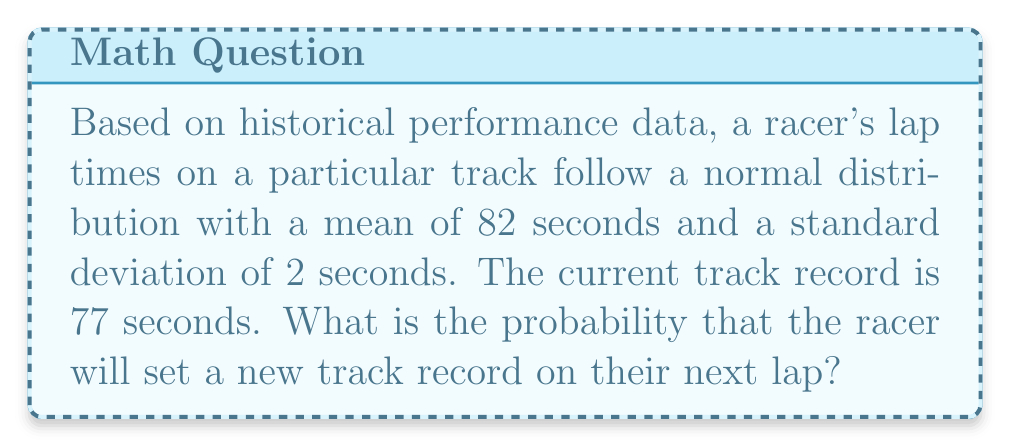Help me with this question. Let's approach this step-by-step:

1) We are given that the lap times follow a normal distribution with:
   $\mu = 82$ seconds (mean)
   $\sigma = 2$ seconds (standard deviation)

2) The track record is 77 seconds. To set a new record, the racer needs to complete a lap in less than 77 seconds.

3) We need to find $P(X < 77)$, where $X$ is the random variable representing the racer's lap time.

4) To use the standard normal distribution, we need to standardize our value:

   $z = \frac{x - \mu}{\sigma} = \frac{77 - 82}{2} = -2.5$

5) Now we need to find $P(Z < -2.5)$ using the standard normal distribution table.

6) From the table, we find that $P(Z < -2.5) \approx 0.0062$

7) This means there is approximately a 0.62% chance that the racer will set a new track record on their next lap.
Answer: $0.0062$ or $0.62\%$ 